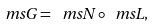Convert formula to latex. <formula><loc_0><loc_0><loc_500><loc_500>\ m s { G } = \ m s { N } \circ \ m s { L } ,</formula> 